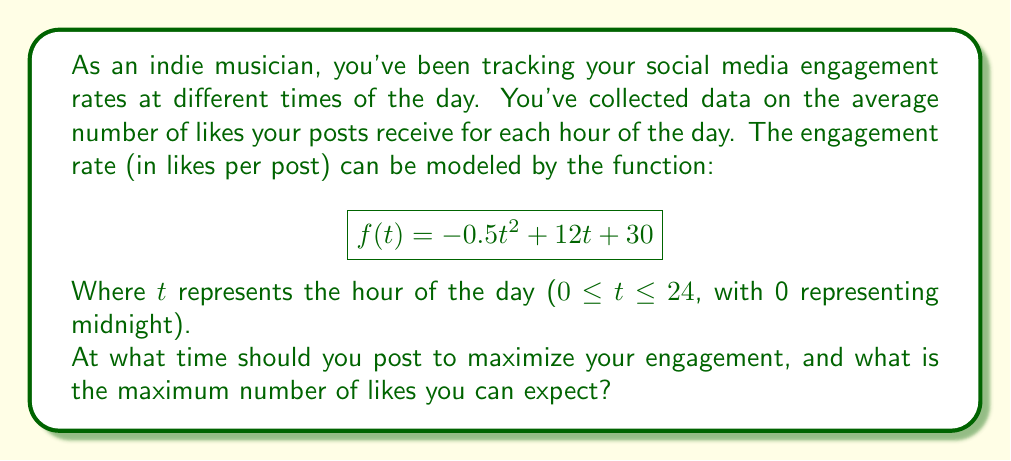Could you help me with this problem? To solve this problem, we need to find the maximum value of the quadratic function $f(t) = -0.5t^2 + 12t + 30$ within the domain 0 ≤ t ≤ 24.

1. First, we need to find the vertex of the parabola, which represents the maximum point. For a quadratic function in the form $f(t) = at^2 + bt + c$, the t-coordinate of the vertex is given by $t = -\frac{b}{2a}$.

2. In our case, $a = -0.5$ and $b = 12$. So:

   $$t = -\frac{12}{2(-0.5)} = -\frac{12}{-1} = 12$$

3. This means the maximum engagement occurs at t = 12, which corresponds to 12:00 PM (noon).

4. To find the maximum number of likes, we substitute t = 12 into the original function:

   $$f(12) = -0.5(12)^2 + 12(12) + 30$$
   $$= -0.5(144) + 144 + 30$$
   $$= -72 + 144 + 30$$
   $$= 102$$

5. We should verify that this is indeed within our domain of 0 ≤ t ≤ 24, which it is.

Therefore, the optimal time to post is at 12:00 PM (noon), and the maximum expected number of likes is 102.
Answer: Optimal posting time: 12:00 PM (noon)
Maximum expected likes: 102 